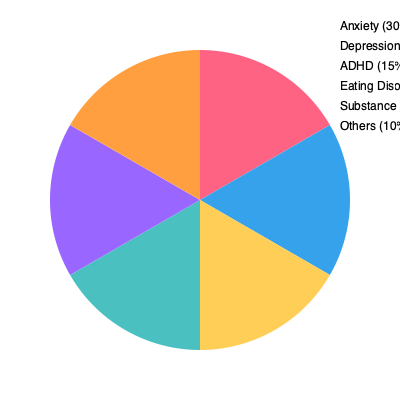Based on the pie chart representing common mental health issues among teenagers, what percentage of adolescents are affected by anxiety and depression combined? To find the percentage of adolescents affected by anxiety and depression combined, we need to follow these steps:

1. Identify the percentages for anxiety and depression from the pie chart:
   - Anxiety: 30%
   - Depression: 25%

2. Add these two percentages together:
   $30\% + 25\% = 55\%$

Therefore, the percentage of adolescents affected by anxiety and depression combined is 55%.

This information is crucial for a youth center coordinator organizing workshops on adolescent mental health, as it highlights the significance of focusing on anxiety and depression in their programs, given that these two issues affect more than half of the teenagers with mental health concerns.
Answer: 55% 